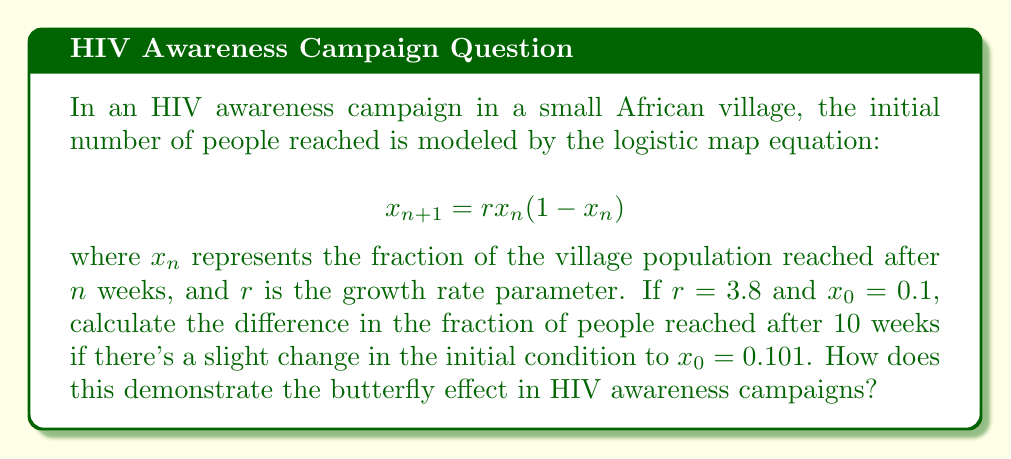Solve this math problem. 1. We need to iterate the logistic map equation for both initial conditions:
   $x_0 = 0.1$ and $x_0 = 0.101$

2. For $x_0 = 0.1$:
   $x_1 = 3.8 * 0.1 * (1-0.1) = 0.342$
   $x_2 = 3.8 * 0.342 * (1-0.342) = 0.855$
   ...
   (Continue iterating until $x_{10}$)

3. For $x_0 = 0.101$:
   $x_1 = 3.8 * 0.101 * (1-0.101) = 0.345$
   $x_2 = 3.8 * 0.345 * (1-0.345) = 0.860$
   ...
   (Continue iterating until $x_{10}$)

4. After 10 iterations:
   For $x_0 = 0.1$: $x_{10} \approx 0.8976$
   For $x_0 = 0.101$: $x_{10} \approx 0.5231$

5. Calculate the difference:
   $|0.8976 - 0.5231| = 0.3745$

6. This demonstrates the butterfly effect because a small change in the initial condition (0.001 or 0.1% difference) leads to a significant difference in the outcome after just 10 weeks (37.45% difference). In the context of HIV awareness campaigns, this shows how small initial differences in outreach efforts can lead to vastly different long-term outcomes in the number of people reached and potentially impacted by the campaign.
Answer: 0.3745 (37.45% difference) 